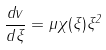Convert formula to latex. <formula><loc_0><loc_0><loc_500><loc_500>\frac { d v } { d \xi } = \mu \chi ( \xi ) \xi ^ { 2 }</formula> 